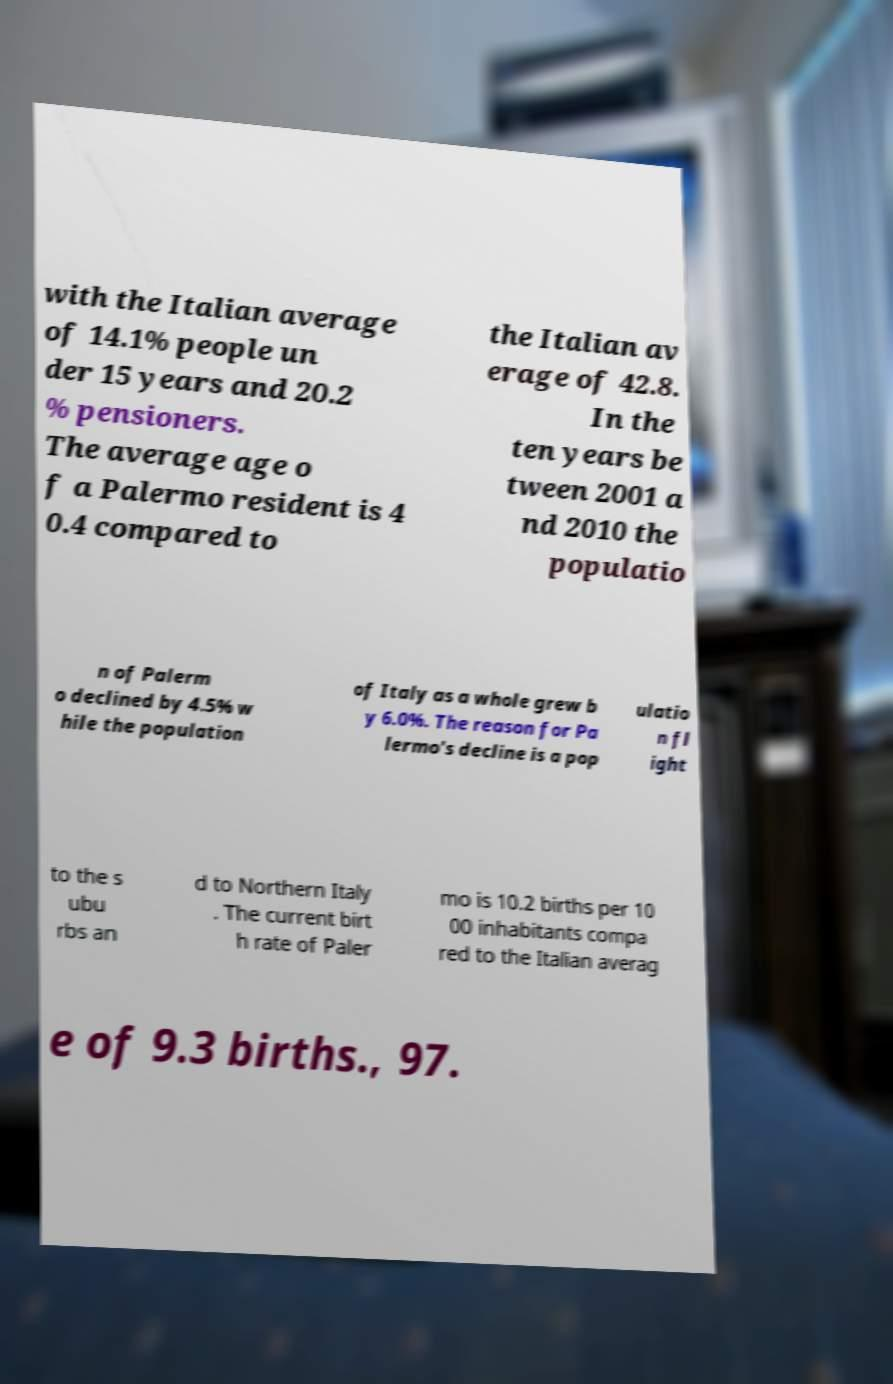Can you accurately transcribe the text from the provided image for me? with the Italian average of 14.1% people un der 15 years and 20.2 % pensioners. The average age o f a Palermo resident is 4 0.4 compared to the Italian av erage of 42.8. In the ten years be tween 2001 a nd 2010 the populatio n of Palerm o declined by 4.5% w hile the population of Italy as a whole grew b y 6.0%. The reason for Pa lermo's decline is a pop ulatio n fl ight to the s ubu rbs an d to Northern Italy . The current birt h rate of Paler mo is 10.2 births per 10 00 inhabitants compa red to the Italian averag e of 9.3 births., 97. 